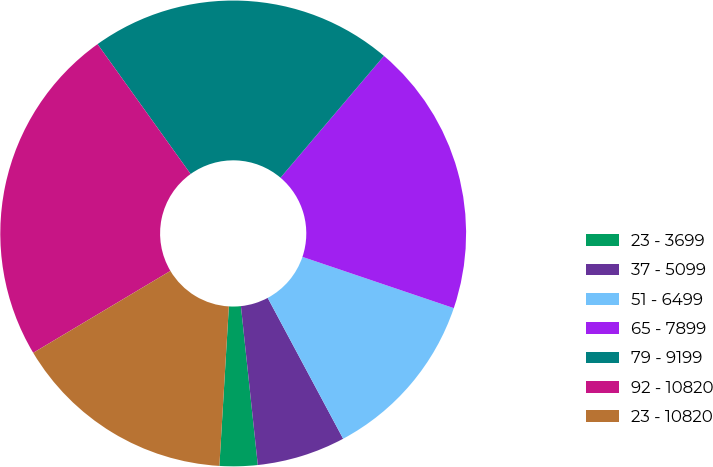Convert chart to OTSL. <chart><loc_0><loc_0><loc_500><loc_500><pie_chart><fcel>23 - 3699<fcel>37 - 5099<fcel>51 - 6499<fcel>65 - 7899<fcel>79 - 9199<fcel>92 - 10820<fcel>23 - 10820<nl><fcel>2.63%<fcel>6.14%<fcel>11.98%<fcel>18.99%<fcel>21.1%<fcel>23.67%<fcel>15.49%<nl></chart> 